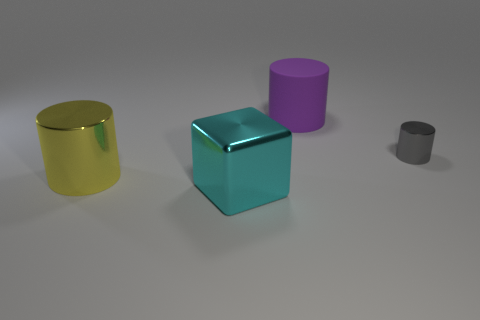Subtract all large cylinders. How many cylinders are left? 1 Add 4 big cyan shiny things. How many objects exist? 8 Subtract all gray cylinders. How many cylinders are left? 2 Subtract all cubes. How many objects are left? 3 Subtract 2 cylinders. How many cylinders are left? 1 Subtract all red cubes. Subtract all cyan balls. How many cubes are left? 1 Subtract all purple cubes. How many red cylinders are left? 0 Subtract all purple rubber cylinders. Subtract all gray shiny objects. How many objects are left? 2 Add 2 purple matte cylinders. How many purple matte cylinders are left? 3 Add 2 tiny gray shiny things. How many tiny gray shiny things exist? 3 